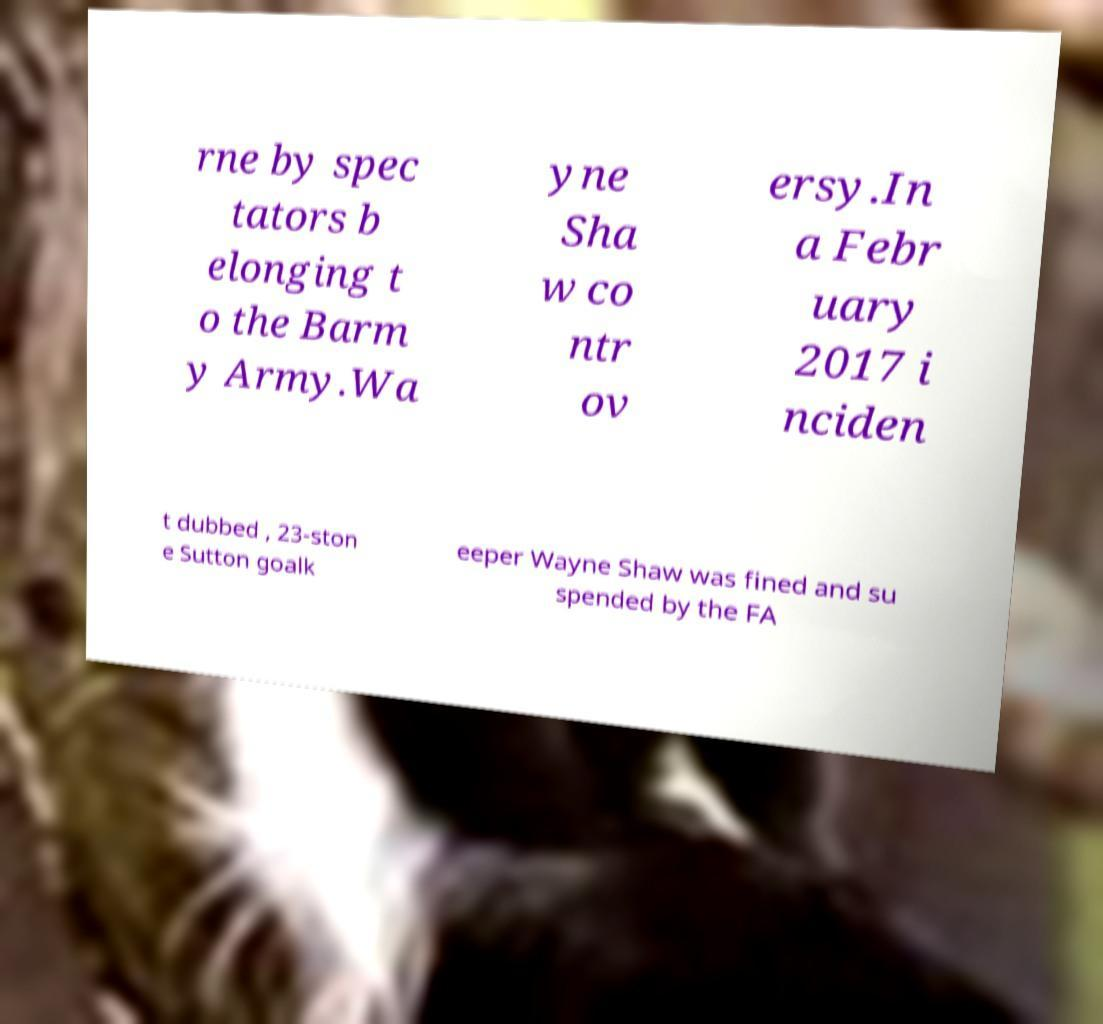I need the written content from this picture converted into text. Can you do that? rne by spec tators b elonging t o the Barm y Army.Wa yne Sha w co ntr ov ersy.In a Febr uary 2017 i nciden t dubbed , 23-ston e Sutton goalk eeper Wayne Shaw was fined and su spended by the FA 